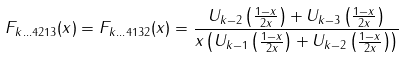Convert formula to latex. <formula><loc_0><loc_0><loc_500><loc_500>F _ { k \dots 4 2 1 3 } ( x ) = F _ { k \dots 4 1 3 2 } ( x ) = \frac { U _ { k - 2 } \left ( \frac { 1 - x } { 2 x } \right ) + U _ { k - 3 } \left ( \frac { 1 - x } { 2 x } \right ) } { x \left ( U _ { k - 1 } \left ( \frac { 1 - x } { 2 x } \right ) + U _ { k - 2 } \left ( \frac { 1 - x } { 2 x } \right ) \right ) }</formula> 